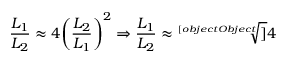<formula> <loc_0><loc_0><loc_500><loc_500>{ \frac { L _ { 1 } } { L _ { 2 } } } \approx 4 { \left ( { \frac { L _ { 2 } } { L _ { 1 } } } \right ) } ^ { 2 } \Rightarrow { \frac { L _ { 1 } } { L _ { 2 } } } \approx { \sqrt { [ } [ o b j e c t O b j e c t ] ] { 4 } } \,</formula> 